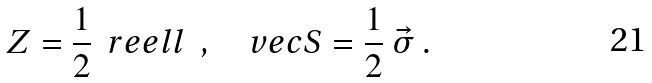Convert formula to latex. <formula><loc_0><loc_0><loc_500><loc_500>Z = \frac { 1 } { 2 } \ { \ r e e l l } \ \ , \quad v e c { S } = \frac { 1 } { 2 } \ \vec { \sigma } \ .</formula> 